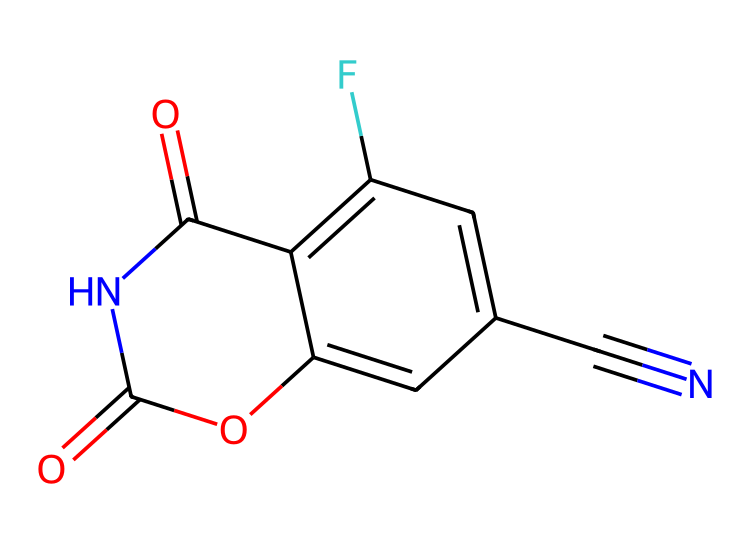What is the molecular formula of fludioxonil? To determine the molecular formula, count the number of each type of atom in the SMILES representation. The elements present are carbon (C), nitrogen (N), oxygen (O), and fluorine (F). By counting the atoms, we find there are 10 carbons, 1 nitrogen, 3 oxygens, and 1 fluorine, leading us to the formula C10H7F3N2O3.
Answer: C10H7F3N2O3 How many rings are present in the structure? Inspect the chemical structure represented in the SMILES. Identify the cyclic parts of the molecule; in this case, there is a five-membered ring (the one containing nitrogen and carbon atoms). Hence, the answer is one.
Answer: 1 What functional groups are present in fludioxonil? Analyze the structure for distinctive features. The presence of the carbonyl groups (C=O), hydroxyl groups (-OH), and the cyano group (-C#N) are observed. These indicate the functional groups of the molecule.
Answer: carbonyl, hydroxyl, cyano What type of bonding is prevalent in the molecule? The structure contains both covalent bonds and polar covalent bonds. As seen in the carbon-nitrogen and carbon-oxygen connections, these bonds contribute to the overall stability and reactivity of the molecule.
Answer: covalent How might the fluorine atom influence the fungicidal activity? The presence of a fluorine atom typically increases chemical stability and lipophilicity, enhancing the ability to penetrate fungal cell membranes. This affects the fungicidal activity.
Answer: increase activity Which part of fludioxonil is primarily responsible for its fungicidal properties? The cyano group (-C#N) and the structure's overall configuration contribute significantly to its mechanism for messing with the cellular processes of fungi. These components have specific interactions with fungal metabolic pathways.
Answer: cyano group 